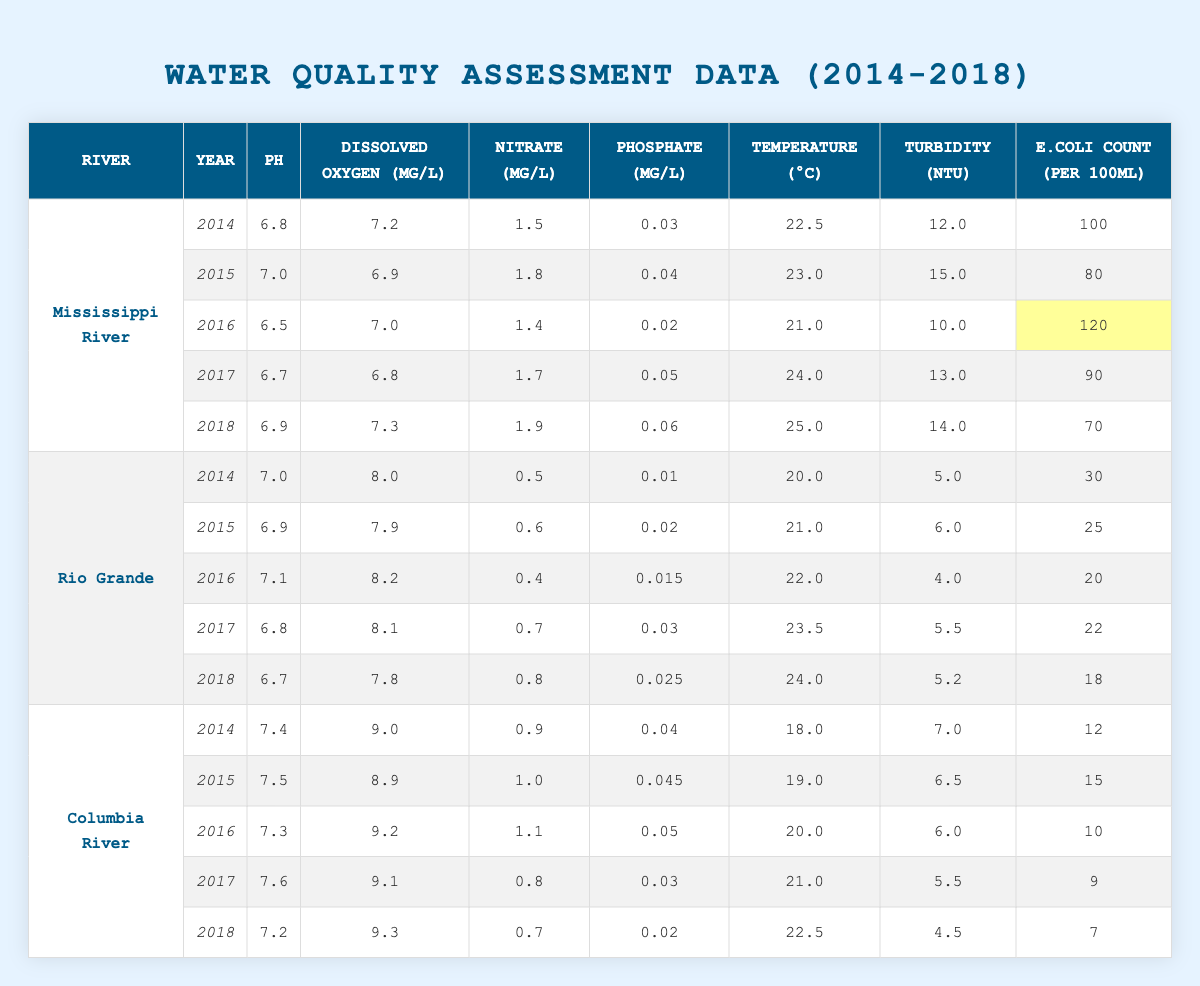What is the pH level of the Rio Grande in 2016? The table shows that for the Rio Grande in 2016, the pH level is listed as 7.1.
Answer: 7.1 What year had the highest E.coli count for the Mississippi River? By examining the Mississippi River data, the highest E.coli count occurred in 2016 with a count of 120.
Answer: 2016 What was the average temperature of the Columbia River from 2014 to 2018? Calculating the average involves summing the temperatures of 2014 (18.0), 2015 (19.0), 2016 (20.0), 2017 (21.0), and 2018 (22.5), giving a sum of 100.5 degrees. Dividing by 5 gives an average of 20.1 degrees.
Answer: 20.1 Is the dissolved oxygen level for the Rio Grande in 2018 more than 7 mg/L? According to the table, the dissolved oxygen level for the Rio Grande in 2018 is 7.8 mg/L, which is higher than 7 mg/L.
Answer: Yes Compare the phosphate levels of the Mississippi River in 2014 and 2018. What is the difference? The phosphate level for the Mississippi River in 2014 is 0.03 mg/L and in 2018 it is 0.06 mg/L. The difference is calculated as 0.06 - 0.03 = 0.03 mg/L.
Answer: 0.03 How does the turbidity of the Columbia River in 2016 compare to that in 2018? The turbidity for the Columbia River in 2016 is 6.0 NTU and in 2018 it is 4.5 NTU. Comparing these values shows the turbidity decreased by 1.5 NTU from 2016 to 2018.
Answer: Decreased by 1.5 NTU What was the maximum nitrate level recorded across all rivers from 2014 to 2018? The highest nitrate level observed is 1.9 mg/L for the Mississippi River in 2018. Other values are lower, so the maximum is confirmed as 1.9 mg/L.
Answer: 1.9 Which river had the lowest E.coli count in 2017? Reviewing the E.coli counts shows that the lowest count in 2017 was for the Columbia River, which had a count of 9 per 100ml.
Answer: Columbia River Did the average pH of the Mississippi River increase or decrease from 2014 to 2018? The pH levels for the Mississippi River from 2014 to 2018 are 6.8, 7.0, 6.5, 6.7, and 6.9. Calculating the average of these values gives approximately 6.78, indicating a slight decrease from the initial 6.8.
Answer: Decrease What is the relationship between temperature and dissolved oxygen for the Columbia River in 2015? The temperature in 2015 was 19.0 °C while the dissolved oxygen was 8.9 mg/L. There isn't a direct quantitative relationship provided in the data, but both parameters can be independently observed.
Answer: Not directly related 